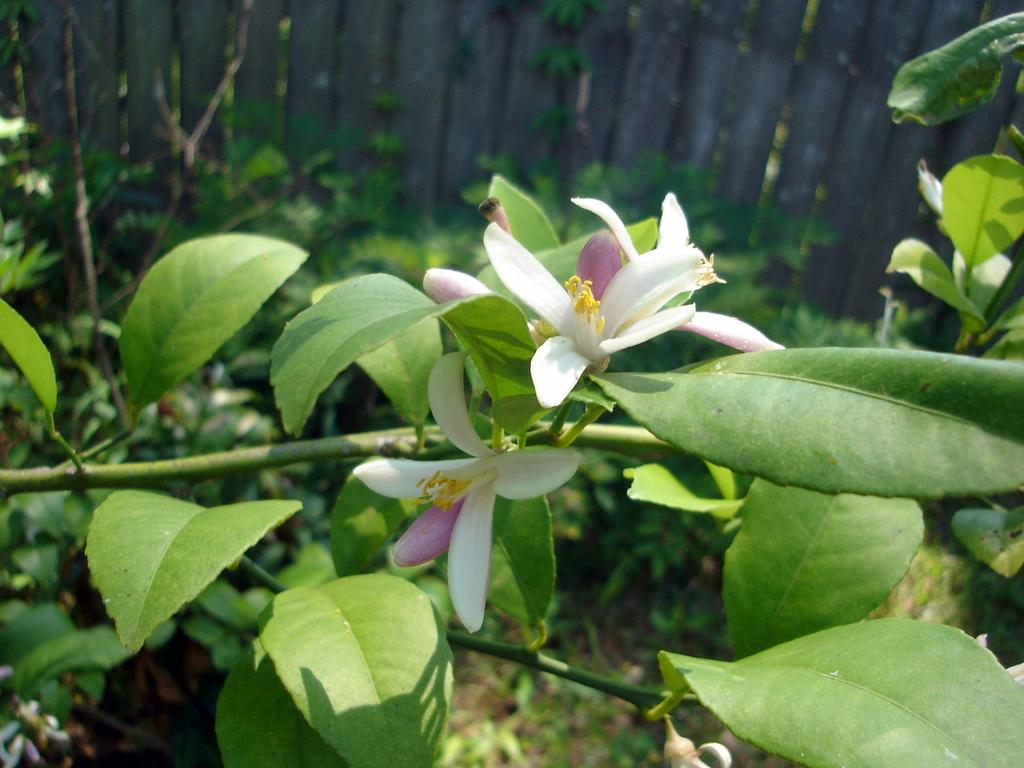What type of living organisms can be seen in the image? There are flowers on plants in the image. What type of material is the fence in the background made of? The fence in the background is made of wood. What card is the queen holding in the image? There is no queen or card present in the image; it features flowers on plants and a wooden fence. 